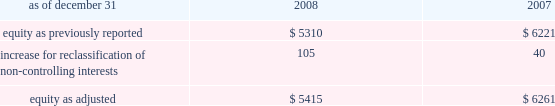The company recognizes the effect of income tax positions only if sustaining those positions is more likely than not .
Changes in recognition or measurement are reflected in the period in which a change in judgment occurs .
The company records penalties and interest related to unrecognized tax benefits in income taxes in the company 2019s consolidated statements of income .
Changes in accounting principles business combinations and noncontrolling interests on january 1 , 2009 , the company adopted revised principles related to business combinations and noncontrolling interests .
The revised principle on business combinations applies to all transactions or other events in which an entity obtains control over one or more businesses .
It requires an acquirer to recognize the assets acquired , the liabilities assumed , and any noncontrolling interest in the acquiree at the acquisition date , measured at their fair values as of that date .
Business combinations achieved in stages require recognition of the identifiable assets and liabilities , as well as the noncontrolling interest in the acquiree , at the full amounts of their fair values when control is obtained .
This revision also changes the requirements for recognizing assets acquired and liabilities assumed arising from contingencies , and requires direct acquisition costs to be expensed .
In addition , it provides certain changes to income tax accounting for business combinations which apply to both new and previously existing business combinations .
In april 2009 , additional guidance was issued which revised certain business combination guidance related to accounting for contingent liabilities assumed in a business combination .
The company has adopted this guidance in conjunction with the adoption of the revised principles related to business combinations .
The adoption of the revised principles related to business combinations has not had a material impact on the consolidated financial statements .
The revised principle related to noncontrolling interests establishes accounting and reporting standards for the noncontrolling interests in a subsidiary and for the deconsolidation of a subsidiary .
The revised principle clarifies that a noncontrolling interest in a subsidiary is an ownership interest in the consolidated entity that should be reported as a separate component of equity in the consolidated statements of financial position .
The revised principle requires retrospective adjustments , for all periods presented , of stockholders 2019 equity and net income for noncontrolling interests .
In addition to these financial reporting changes , the revised principle provides for significant changes in accounting related to changes in ownership of noncontrolling interests .
Changes in aon 2019s controlling financial interests in consolidated subsidiaries that do not result in a loss of control are accounted for as equity transactions similar to treasury stock transactions .
If a change in ownership of a consolidated subsidiary results in a loss of control and deconsolidation , any retained ownership interests are remeasured at fair value with the gain or loss reported in net income .
In previous periods , noncontrolling interests for operating subsidiaries were reported in other general expenses in the consolidated statements of income .
Prior period amounts have been restated to conform to the current year 2019s presentation .
The principal effect on the prior years 2019 balance sheets related to the adoption of the new guidance related to noncontrolling interests is summarized as follows ( in millions ) : .
The revised principle also requires that net income be adjusted to include the net income attributable to the noncontrolling interests and a new separate caption for net income attributable to aon stockholders be presented in the consolidated statements of income .
The adoption of this new guidance increased net income by $ 16 million and $ 13 million for 2008 and 2007 , respectively .
Net .
Based on the adoption of the new guidance what was the percent of the increased net income from 2007 to 2008 by $ 16 million and $ 13 million for 2008 and 2007,? 
Computations: ((16 - 13) / 13)
Answer: 0.23077. 